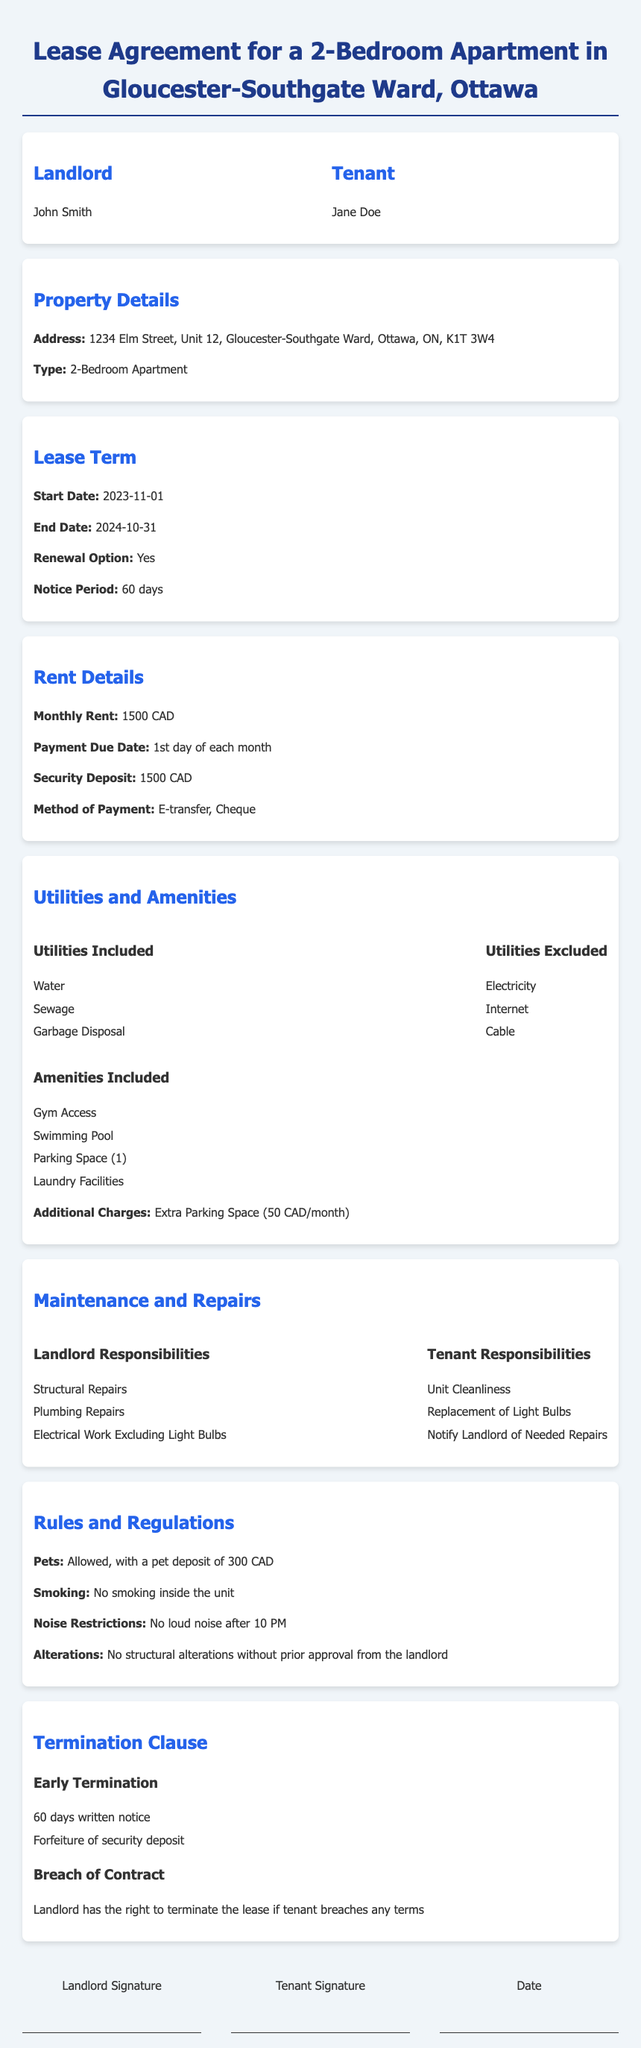What is the name of the landlord? The name of the landlord is specified in the document under the Landlord section.
Answer: John Smith What is the monthly rent for the apartment? The monthly rent is stated in the Rent Details section of the document.
Answer: 1500 CAD What is the start date of the lease? The start date of the lease is mentioned in the Lease Term section.
Answer: 2023-11-01 What utilities are included in the rent? The included utilities are listed under the Utilities Included section of the document.
Answer: Water, Sewage, Garbage Disposal What is the pet deposit amount? The pet deposit amount is detailed in the Rules and Regulations section.
Answer: 300 CAD Who is responsible for plumbing repairs? The responsibilities for plumbing repairs are outlined in the Maintenance and Repairs section.
Answer: Landlord What is the notice period for lease renewal? The notice period for lease renewal is specified in the Lease Term section.
Answer: 60 days What is the additional charge for an extra parking space? The additional charge for extra parking is mentioned under the Utilities and Amenities section.
Answer: 50 CAD/month What happens if the tenant breaches the contract? The breach of contract consequences are detailed in the Termination Clause section.
Answer: Landlord has the right to terminate the lease 